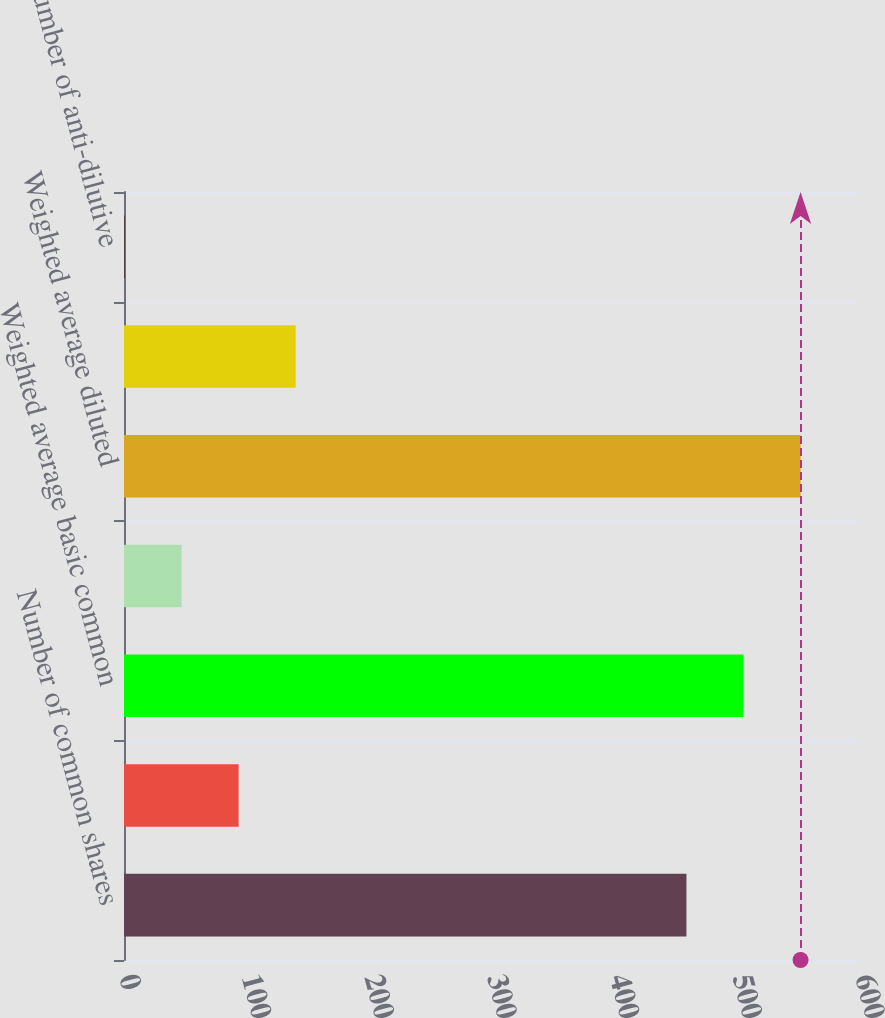Convert chart. <chart><loc_0><loc_0><loc_500><loc_500><bar_chart><fcel>Number of common shares<fcel>Effect of using weighted<fcel>Weighted average basic common<fcel>Dilutive effect of<fcel>Weighted average diluted<fcel>Potentially issuable shares<fcel>Number of anti-dilutive<nl><fcel>458.5<fcel>93.44<fcel>505.02<fcel>46.92<fcel>551.54<fcel>139.96<fcel>0.4<nl></chart> 